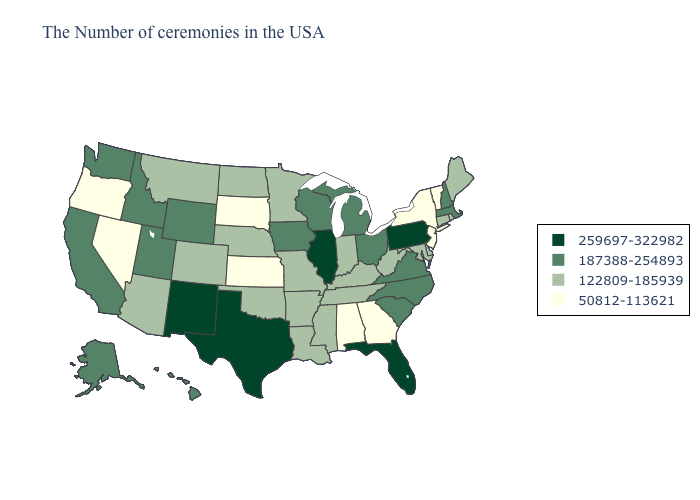What is the lowest value in the USA?
Keep it brief. 50812-113621. Name the states that have a value in the range 50812-113621?
Be succinct. Vermont, New York, New Jersey, Georgia, Alabama, Kansas, South Dakota, Nevada, Oregon. Name the states that have a value in the range 187388-254893?
Give a very brief answer. Massachusetts, New Hampshire, Virginia, North Carolina, South Carolina, Ohio, Michigan, Wisconsin, Iowa, Wyoming, Utah, Idaho, California, Washington, Alaska, Hawaii. Does Missouri have the highest value in the USA?
Quick response, please. No. What is the highest value in the Northeast ?
Give a very brief answer. 259697-322982. Among the states that border New Mexico , which have the highest value?
Write a very short answer. Texas. Among the states that border Oklahoma , does Texas have the lowest value?
Write a very short answer. No. How many symbols are there in the legend?
Short answer required. 4. Name the states that have a value in the range 259697-322982?
Be succinct. Pennsylvania, Florida, Illinois, Texas, New Mexico. What is the lowest value in the USA?
Be succinct. 50812-113621. Among the states that border Oklahoma , which have the highest value?
Answer briefly. Texas, New Mexico. Does New Hampshire have the lowest value in the USA?
Be succinct. No. What is the value of Maryland?
Give a very brief answer. 122809-185939. Does the first symbol in the legend represent the smallest category?
Answer briefly. No. What is the highest value in the Northeast ?
Be succinct. 259697-322982. 